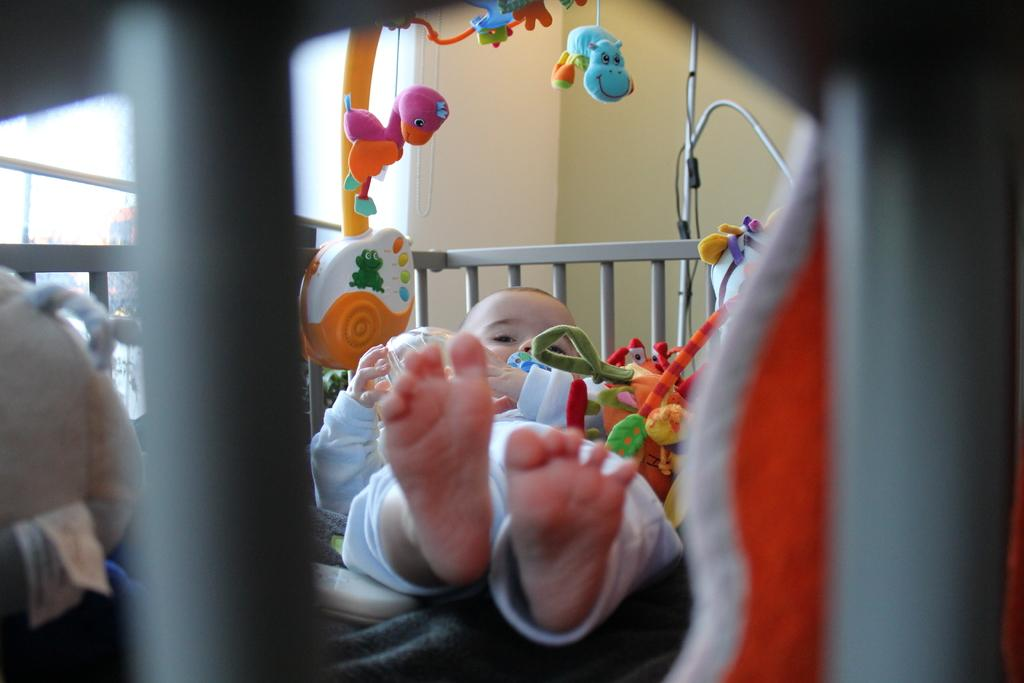What is the kid doing in the image? The kid is sleeping in the cradle. What else can be seen in the image besides the sleeping kid? There are toys in the image. What is visible in the background of the image? There is a wall in the background of the image. How many rabbits can be seen playing with the toys in the image? There are no rabbits present in the image; it features a kid sleeping in a cradle and toys. What type of design is visible on the wall in the background? The provided facts do not mention any specific design on the wall; it is simply described as a wall in the background. 